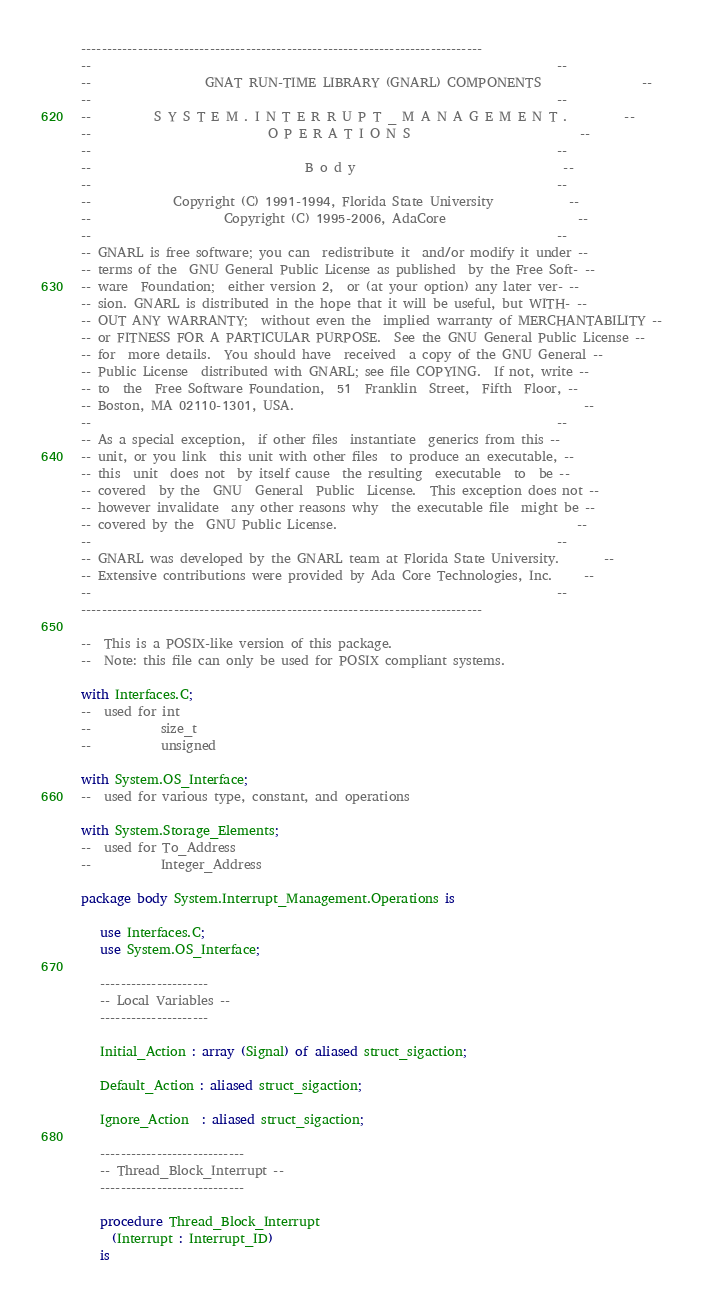Convert code to text. <code><loc_0><loc_0><loc_500><loc_500><_Ada_>------------------------------------------------------------------------------
--                                                                          --
--                  GNAT RUN-TIME LIBRARY (GNARL) COMPONENTS                --
--                                                                          --
--          S Y S T E M . I N T E R R U P T _ M A N A G E M E N T .         --
--                            O P E R A T I O N S                           --
--                                                                          --
--                                  B o d y                                 --
--                                                                          --
--             Copyright (C) 1991-1994, Florida State University            --
--                     Copyright (C) 1995-2006, AdaCore                     --
--                                                                          --
-- GNARL is free software; you can  redistribute it  and/or modify it under --
-- terms of the  GNU General Public License as published  by the Free Soft- --
-- ware  Foundation;  either version 2,  or (at your option) any later ver- --
-- sion. GNARL is distributed in the hope that it will be useful, but WITH- --
-- OUT ANY WARRANTY;  without even the  implied warranty of MERCHANTABILITY --
-- or FITNESS FOR A PARTICULAR PURPOSE.  See the GNU General Public License --
-- for  more details.  You should have  received  a copy of the GNU General --
-- Public License  distributed with GNARL; see file COPYING.  If not, write --
-- to  the  Free Software Foundation,  51  Franklin  Street,  Fifth  Floor, --
-- Boston, MA 02110-1301, USA.                                              --
--                                                                          --
-- As a special exception,  if other files  instantiate  generics from this --
-- unit, or you link  this unit with other files  to produce an executable, --
-- this  unit  does not  by itself cause  the resulting  executable  to  be --
-- covered  by the  GNU  General  Public  License.  This exception does not --
-- however invalidate  any other reasons why  the executable file  might be --
-- covered by the  GNU Public License.                                      --
--                                                                          --
-- GNARL was developed by the GNARL team at Florida State University.       --
-- Extensive contributions were provided by Ada Core Technologies, Inc.     --
--                                                                          --
------------------------------------------------------------------------------

--  This is a POSIX-like version of this package.
--  Note: this file can only be used for POSIX compliant systems.

with Interfaces.C;
--  used for int
--           size_t
--           unsigned

with System.OS_Interface;
--  used for various type, constant, and operations

with System.Storage_Elements;
--  used for To_Address
--           Integer_Address

package body System.Interrupt_Management.Operations is

   use Interfaces.C;
   use System.OS_Interface;

   ---------------------
   -- Local Variables --
   ---------------------

   Initial_Action : array (Signal) of aliased struct_sigaction;

   Default_Action : aliased struct_sigaction;

   Ignore_Action  : aliased struct_sigaction;

   ----------------------------
   -- Thread_Block_Interrupt --
   ----------------------------

   procedure Thread_Block_Interrupt
     (Interrupt : Interrupt_ID)
   is</code> 